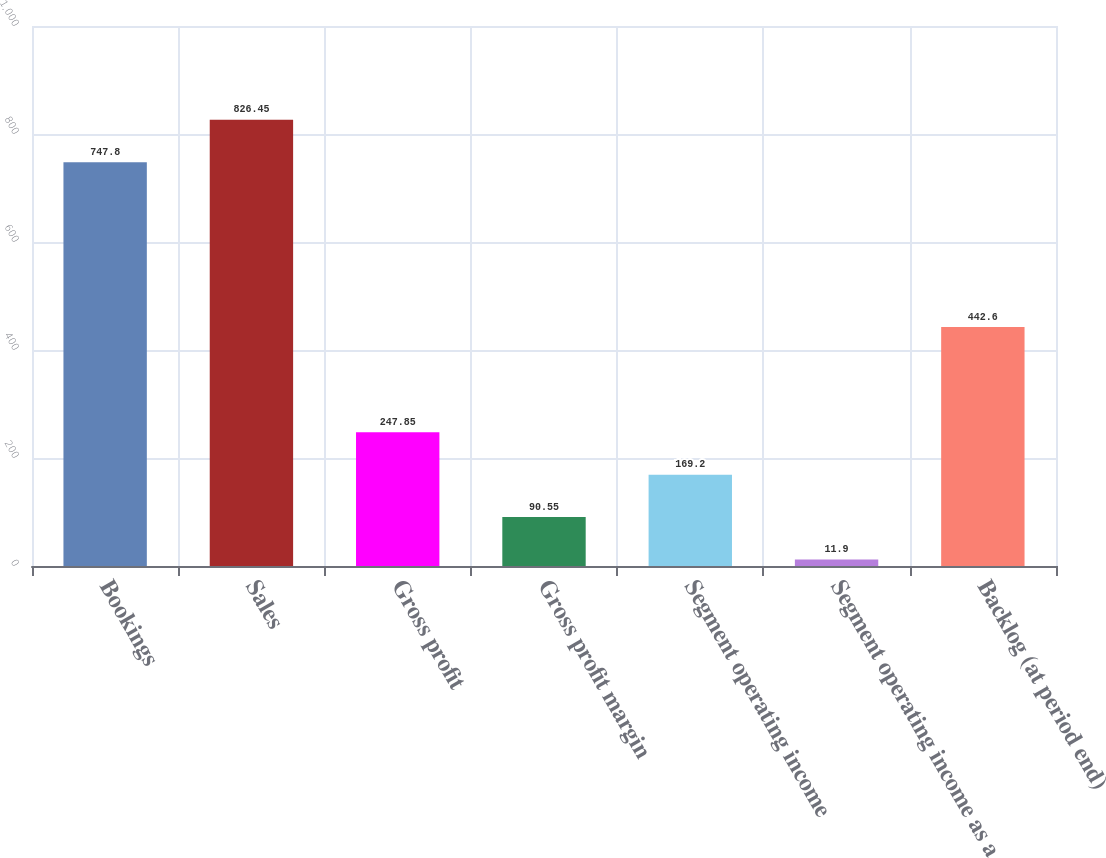Convert chart to OTSL. <chart><loc_0><loc_0><loc_500><loc_500><bar_chart><fcel>Bookings<fcel>Sales<fcel>Gross profit<fcel>Gross profit margin<fcel>Segment operating income<fcel>Segment operating income as a<fcel>Backlog (at period end)<nl><fcel>747.8<fcel>826.45<fcel>247.85<fcel>90.55<fcel>169.2<fcel>11.9<fcel>442.6<nl></chart> 